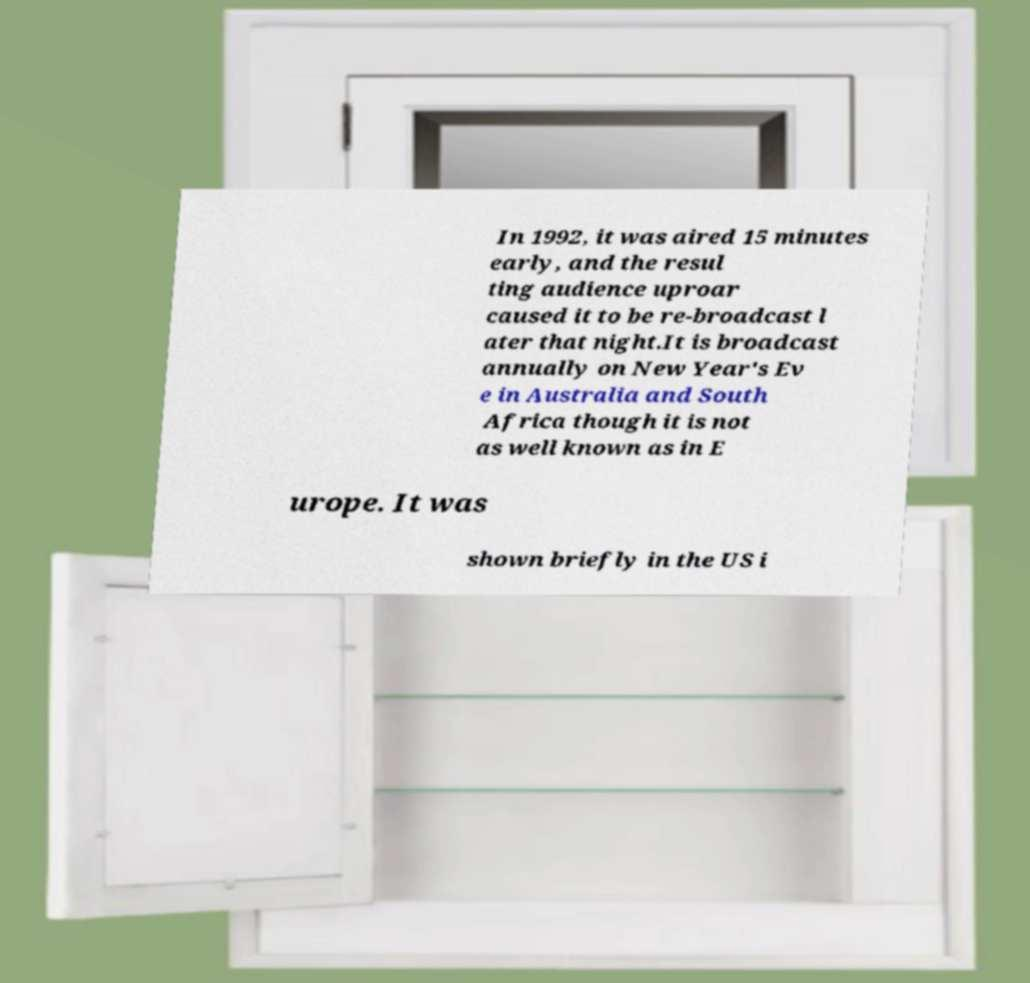Could you extract and type out the text from this image? In 1992, it was aired 15 minutes early, and the resul ting audience uproar caused it to be re-broadcast l ater that night.It is broadcast annually on New Year's Ev e in Australia and South Africa though it is not as well known as in E urope. It was shown briefly in the US i 